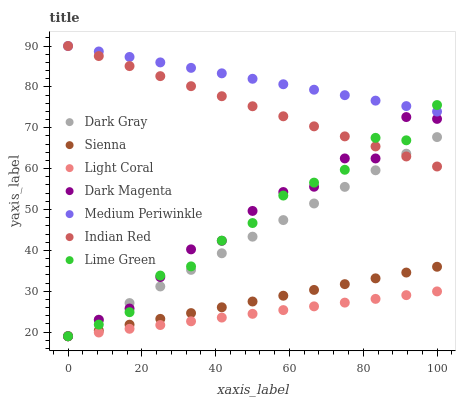Does Light Coral have the minimum area under the curve?
Answer yes or no. Yes. Does Medium Periwinkle have the maximum area under the curve?
Answer yes or no. Yes. Does Dark Magenta have the minimum area under the curve?
Answer yes or no. No. Does Dark Magenta have the maximum area under the curve?
Answer yes or no. No. Is Sienna the smoothest?
Answer yes or no. Yes. Is Dark Magenta the roughest?
Answer yes or no. Yes. Is Medium Periwinkle the smoothest?
Answer yes or no. No. Is Medium Periwinkle the roughest?
Answer yes or no. No. Does Sienna have the lowest value?
Answer yes or no. Yes. Does Medium Periwinkle have the lowest value?
Answer yes or no. No. Does Indian Red have the highest value?
Answer yes or no. Yes. Does Dark Magenta have the highest value?
Answer yes or no. No. Is Light Coral less than Indian Red?
Answer yes or no. Yes. Is Medium Periwinkle greater than Dark Gray?
Answer yes or no. Yes. Does Light Coral intersect Lime Green?
Answer yes or no. Yes. Is Light Coral less than Lime Green?
Answer yes or no. No. Is Light Coral greater than Lime Green?
Answer yes or no. No. Does Light Coral intersect Indian Red?
Answer yes or no. No. 